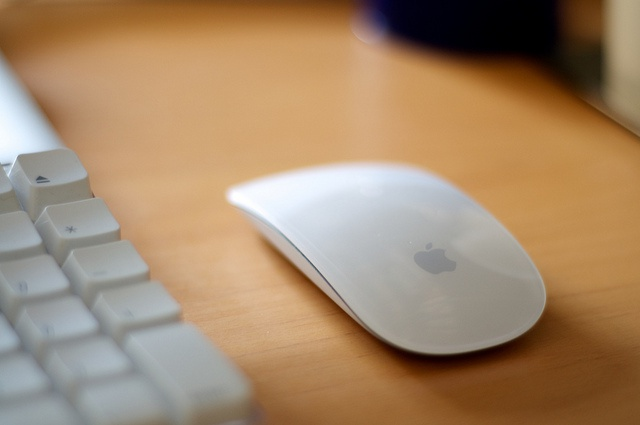Describe the objects in this image and their specific colors. I can see keyboard in tan, darkgray, gray, and lavender tones and mouse in tan, darkgray, lightgray, and gray tones in this image. 